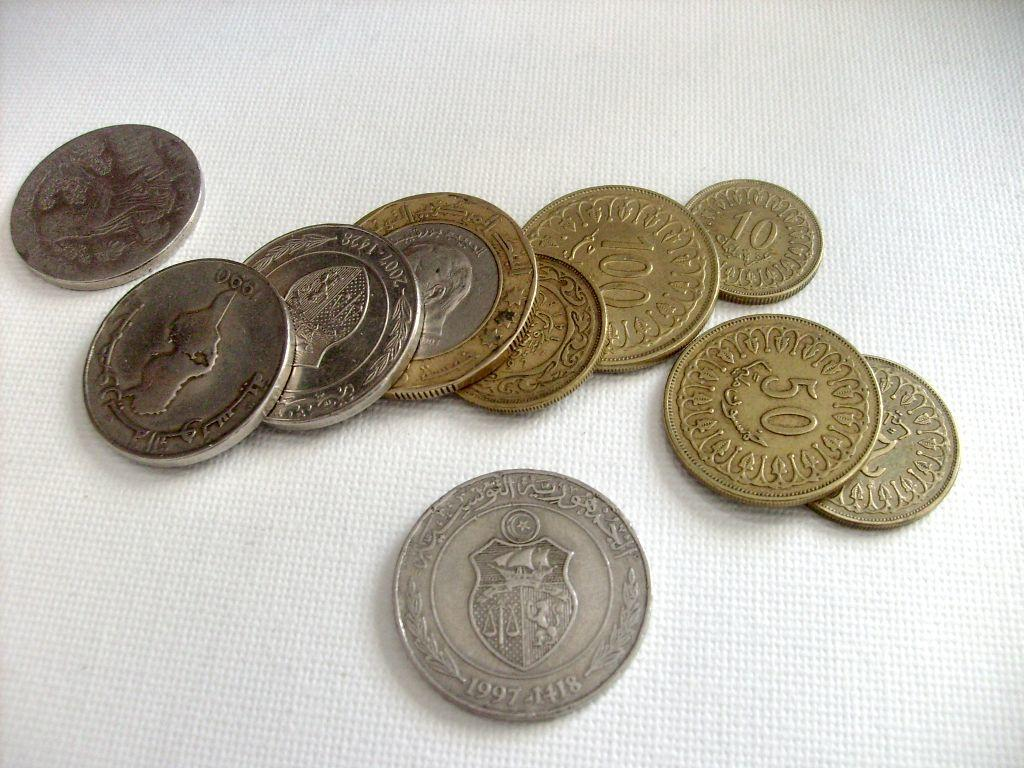Provide a one-sentence caption for the provided image. a 50 cent piece on the ground with other. 